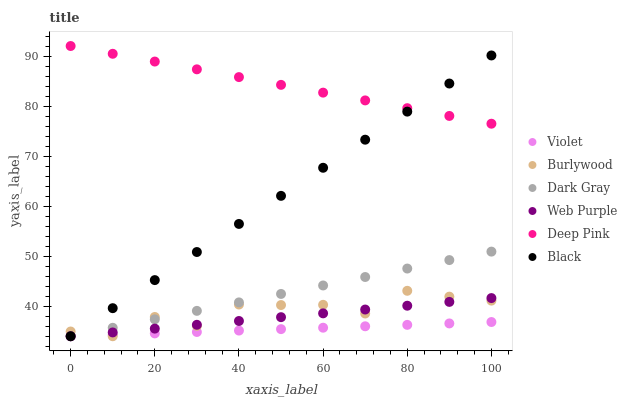Does Violet have the minimum area under the curve?
Answer yes or no. Yes. Does Deep Pink have the maximum area under the curve?
Answer yes or no. Yes. Does Burlywood have the minimum area under the curve?
Answer yes or no. No. Does Burlywood have the maximum area under the curve?
Answer yes or no. No. Is Web Purple the smoothest?
Answer yes or no. Yes. Is Burlywood the roughest?
Answer yes or no. Yes. Is Dark Gray the smoothest?
Answer yes or no. No. Is Dark Gray the roughest?
Answer yes or no. No. Does Burlywood have the lowest value?
Answer yes or no. Yes. Does Deep Pink have the highest value?
Answer yes or no. Yes. Does Burlywood have the highest value?
Answer yes or no. No. Is Dark Gray less than Deep Pink?
Answer yes or no. Yes. Is Deep Pink greater than Violet?
Answer yes or no. Yes. Does Burlywood intersect Violet?
Answer yes or no. Yes. Is Burlywood less than Violet?
Answer yes or no. No. Is Burlywood greater than Violet?
Answer yes or no. No. Does Dark Gray intersect Deep Pink?
Answer yes or no. No. 